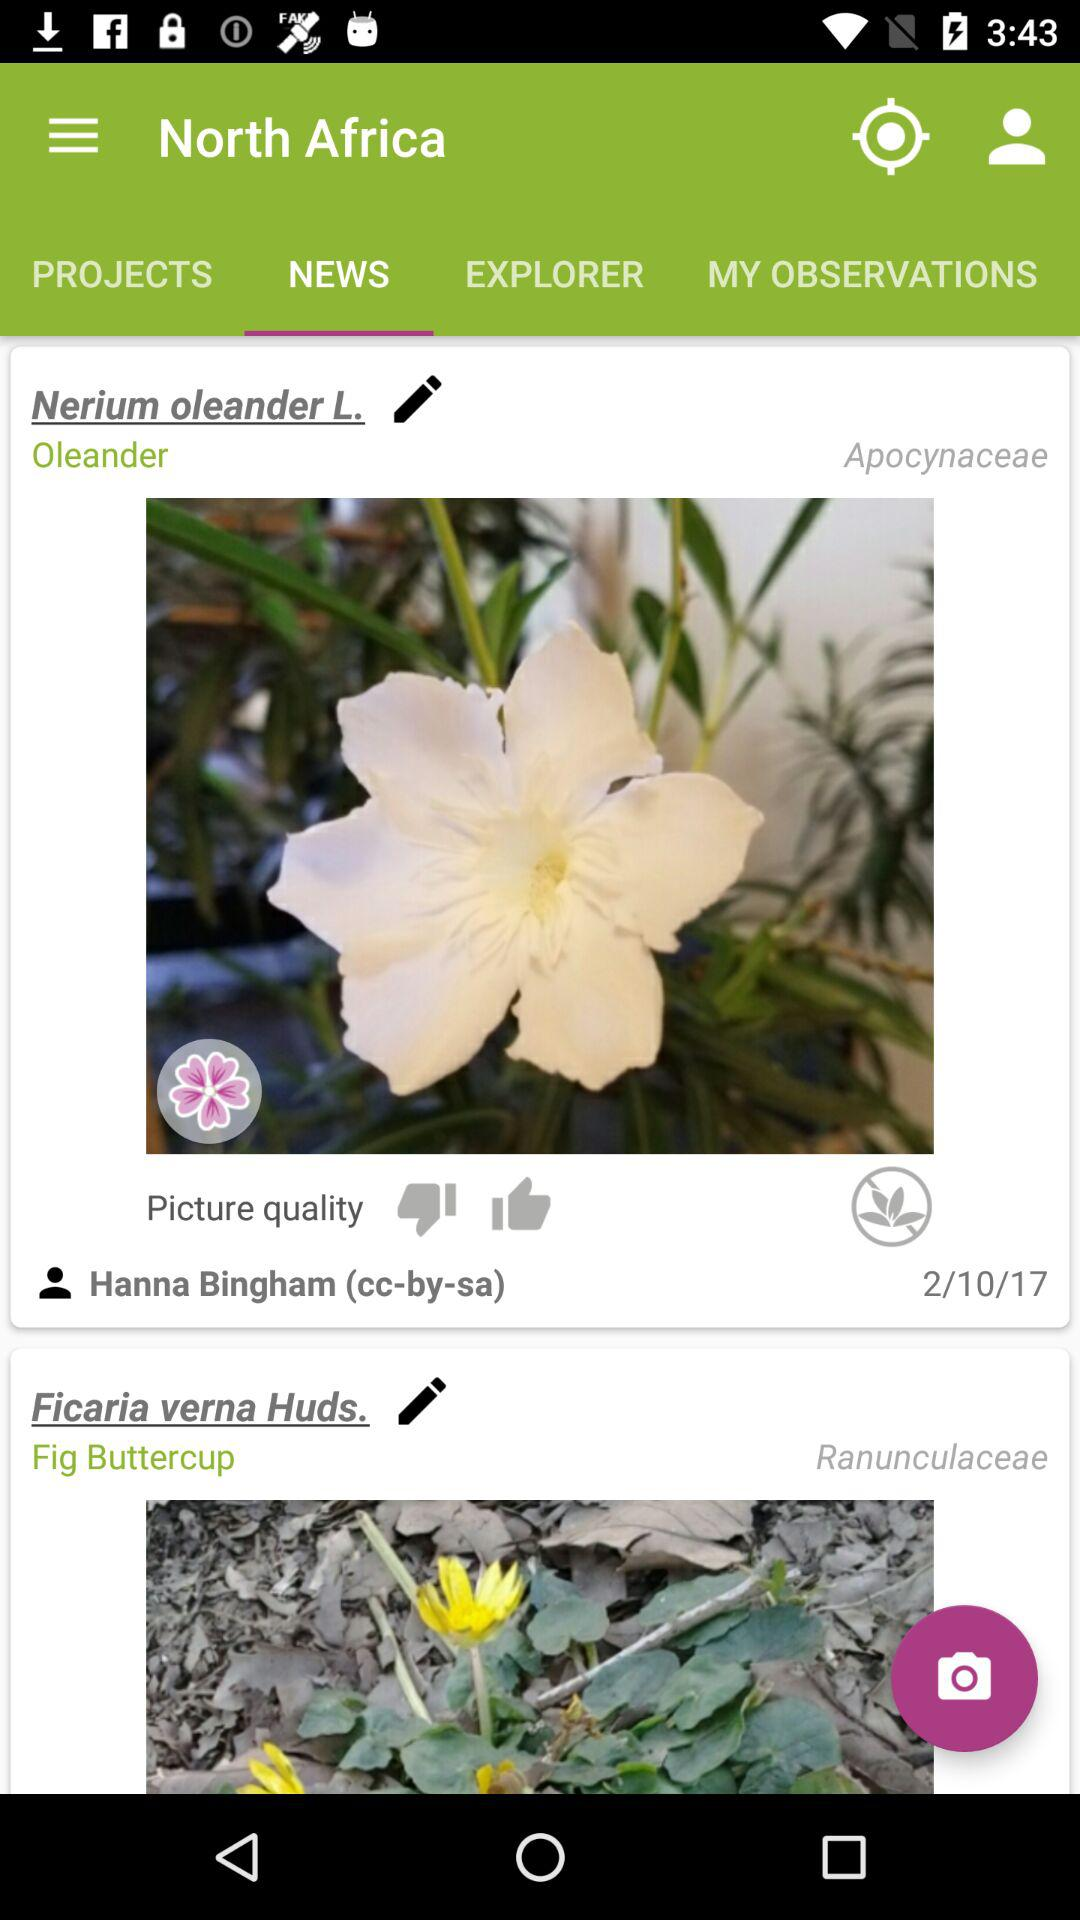What is the given country's name? The given country's name is North Africa. 